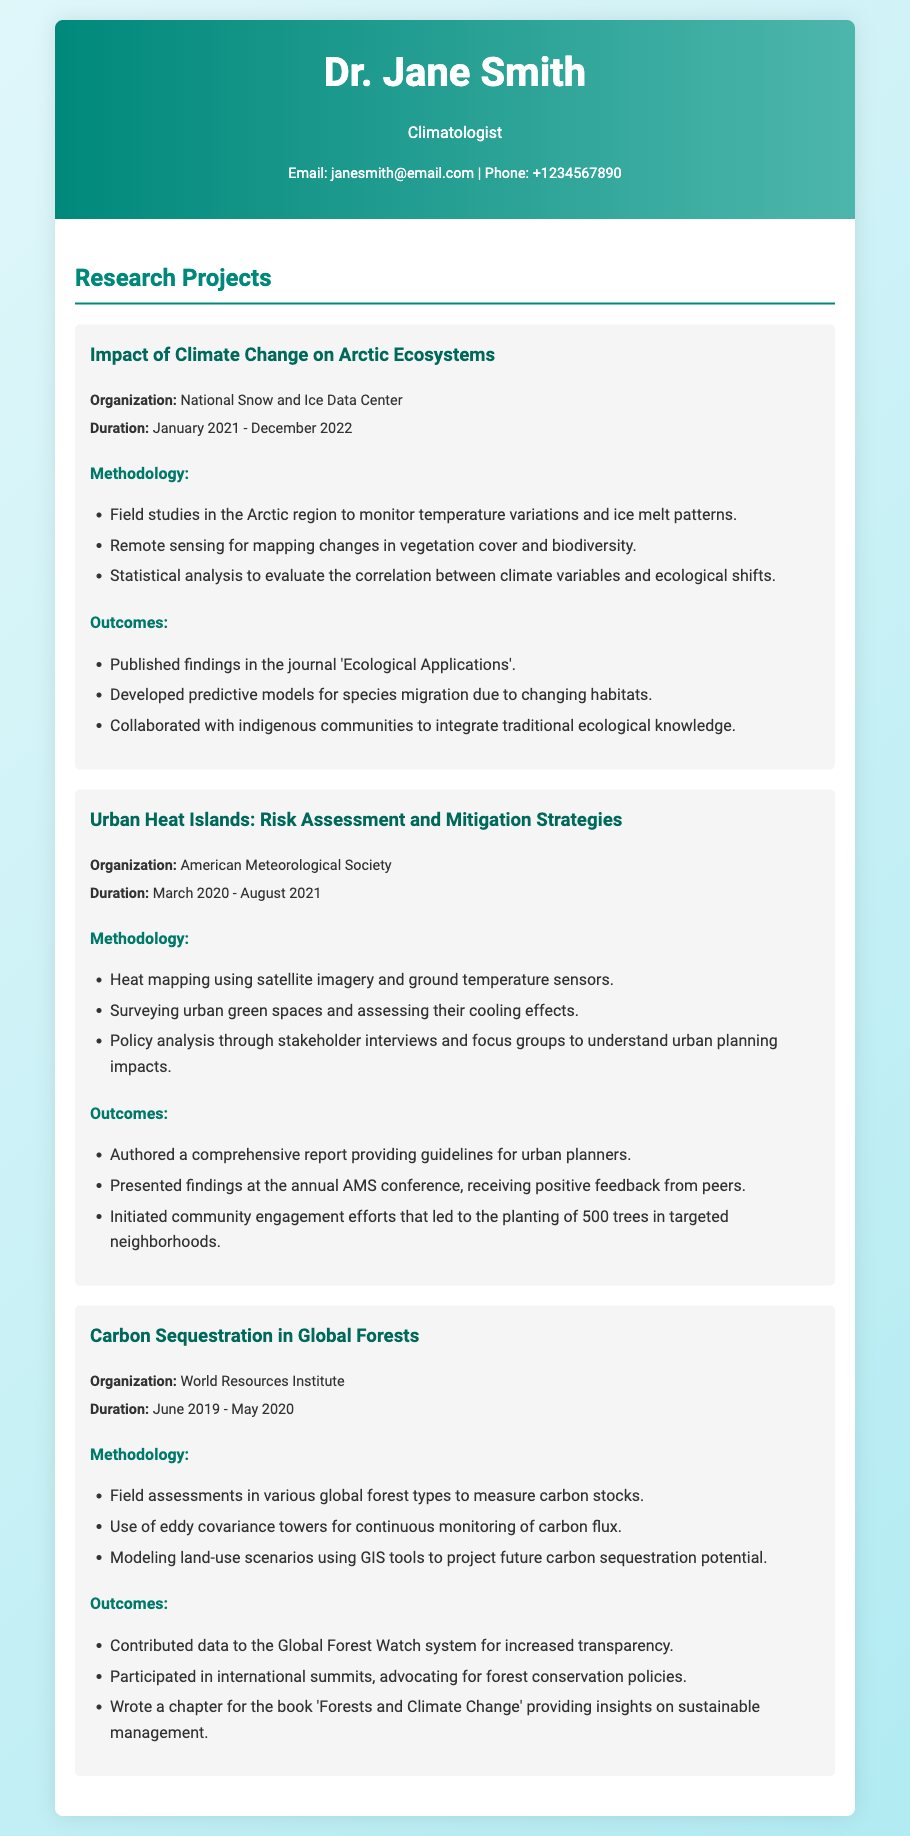What is the duration of the project "Impact of Climate Change on Arctic Ecosystems"? The duration is specified as January 2021 - December 2022.
Answer: January 2021 - December 2022 Which organization conducted the "Urban Heat Islands: Risk Assessment and Mitigation Strategies" project? The organization listed for this project is the American Meteorological Society.
Answer: American Meteorological Society What methodology was used for the carbon sequestration study? The methodologies included field assessments in various global forest types to measure carbon stocks, and more specifically the use of eddy covariance towers.
Answer: Field assessments and eddy covariance towers How many trees were planted as a result of community engagement efforts from the "Urban Heat Islands" project? The outcome mentions that 500 trees were planted in targeted neighborhoods as a community effort.
Answer: 500 trees What was published in 'Ecological Applications'? It was the findings from the project "Impact of Climate Change on Arctic Ecosystems".
Answer: Findings from the project What was one of the outcomes related to international policy from the "Carbon Sequestration in Global Forests" project? Participation in international summits advocating for forest conservation policies was a noted outcome.
Answer: Advocating for forest conservation policies 